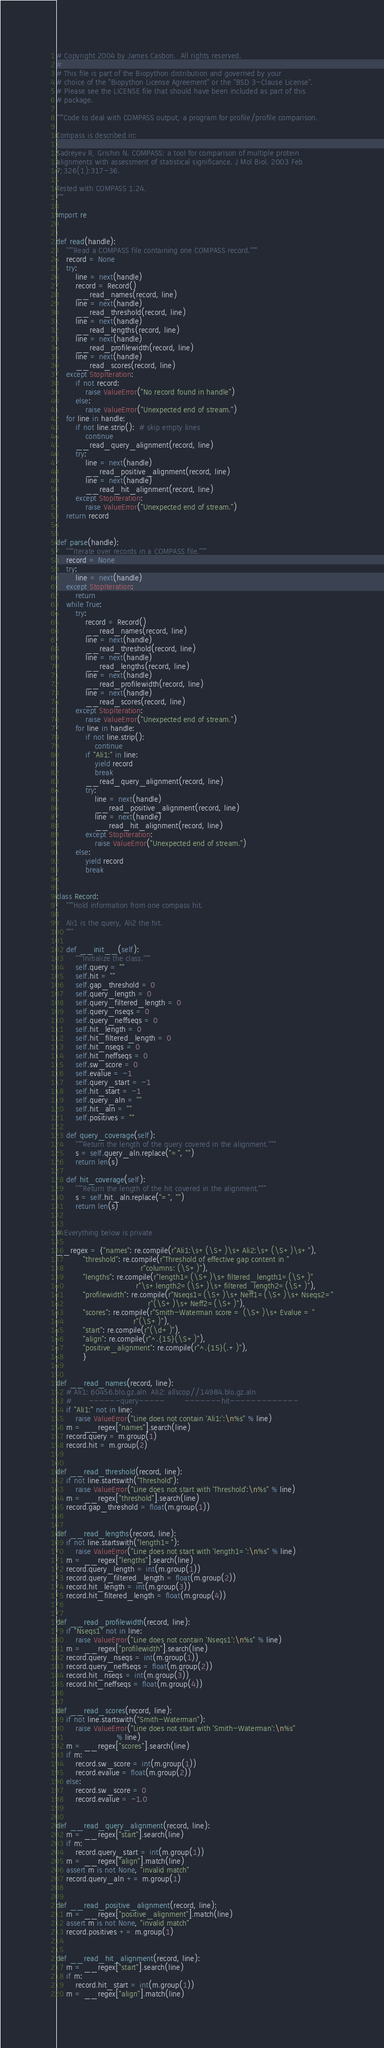<code> <loc_0><loc_0><loc_500><loc_500><_Python_># Copyright 2004 by James Casbon.  All rights reserved.
#
# This file is part of the Biopython distribution and governed by your
# choice of the "Biopython License Agreement" or the "BSD 3-Clause License".
# Please see the LICENSE file that should have been included as part of this
# package.

"""Code to deal with COMPASS output, a program for profile/profile comparison.

Compass is described in:

Sadreyev R, Grishin N. COMPASS: a tool for comparison of multiple protein
alignments with assessment of statistical significance. J Mol Biol. 2003 Feb
7;326(1):317-36.

Tested with COMPASS 1.24.
"""

import re


def read(handle):
    """Read a COMPASS file containing one COMPASS record."""
    record = None
    try:
        line = next(handle)
        record = Record()
        __read_names(record, line)
        line = next(handle)
        __read_threshold(record, line)
        line = next(handle)
        __read_lengths(record, line)
        line = next(handle)
        __read_profilewidth(record, line)
        line = next(handle)
        __read_scores(record, line)
    except StopIteration:
        if not record:
            raise ValueError("No record found in handle")
        else:
            raise ValueError("Unexpected end of stream.")
    for line in handle:
        if not line.strip():  # skip empty lines
            continue
        __read_query_alignment(record, line)
        try:
            line = next(handle)
            __read_positive_alignment(record, line)
            line = next(handle)
            __read_hit_alignment(record, line)
        except StopIteration:
            raise ValueError("Unexpected end of stream.")
    return record


def parse(handle):
    """Iterate over records in a COMPASS file."""
    record = None
    try:
        line = next(handle)
    except StopIteration:
        return
    while True:
        try:
            record = Record()
            __read_names(record, line)
            line = next(handle)
            __read_threshold(record, line)
            line = next(handle)
            __read_lengths(record, line)
            line = next(handle)
            __read_profilewidth(record, line)
            line = next(handle)
            __read_scores(record, line)
        except StopIteration:
            raise ValueError("Unexpected end of stream.")
        for line in handle:
            if not line.strip():
                continue
            if "Ali1:" in line:
                yield record
                break
            __read_query_alignment(record, line)
            try:
                line = next(handle)
                __read_positive_alignment(record, line)
                line = next(handle)
                __read_hit_alignment(record, line)
            except StopIteration:
                raise ValueError("Unexpected end of stream.")
        else:
            yield record
            break


class Record:
    """Hold information from one compass hit.

    Ali1 is the query, Ali2 the hit.
    """

    def __init__(self):
        """Initialize the class."""
        self.query = ""
        self.hit = ""
        self.gap_threshold = 0
        self.query_length = 0
        self.query_filtered_length = 0
        self.query_nseqs = 0
        self.query_neffseqs = 0
        self.hit_length = 0
        self.hit_filtered_length = 0
        self.hit_nseqs = 0
        self.hit_neffseqs = 0
        self.sw_score = 0
        self.evalue = -1
        self.query_start = -1
        self.hit_start = -1
        self.query_aln = ""
        self.hit_aln = ""
        self.positives = ""

    def query_coverage(self):
        """Return the length of the query covered in the alignment."""
        s = self.query_aln.replace("=", "")
        return len(s)

    def hit_coverage(self):
        """Return the length of the hit covered in the alignment."""
        s = self.hit_aln.replace("=", "")
        return len(s)


# Everything below is private

__regex = {"names": re.compile(r"Ali1:\s+(\S+)\s+Ali2:\s+(\S+)\s+"),
           "threshold": re.compile(r"Threshold of effective gap content in "
                                   r"columns: (\S+)"),
           "lengths": re.compile(r"length1=(\S+)\s+filtered_length1=(\S+)"
                                 r"\s+length2=(\S+)\s+filtered_length2=(\S+)"),
           "profilewidth": re.compile(r"Nseqs1=(\S+)\s+Neff1=(\S+)\s+Nseqs2="
                                      r"(\S+)\s+Neff2=(\S+)"),
           "scores": re.compile(r"Smith-Waterman score = (\S+)\s+Evalue = "
                                r"(\S+)"),
           "start": re.compile(r"(\d+)"),
           "align": re.compile(r"^.{15}(\S+)"),
           "positive_alignment": re.compile(r"^.{15}(.+)"),
           }


def __read_names(record, line):
    # Ali1: 60456.blo.gz.aln  Ali2: allscop//14984.blo.gz.aln
    #       ------query-----        -------hit-------------
    if "Ali1:" not in line:
        raise ValueError("Line does not contain 'Ali1:':\n%s" % line)
    m = __regex["names"].search(line)
    record.query = m.group(1)
    record.hit = m.group(2)


def __read_threshold(record, line):
    if not line.startswith("Threshold"):
        raise ValueError("Line does not start with 'Threshold':\n%s" % line)
    m = __regex["threshold"].search(line)
    record.gap_threshold = float(m.group(1))


def __read_lengths(record, line):
    if not line.startswith("length1="):
        raise ValueError("Line does not start with 'length1=':\n%s" % line)
    m = __regex["lengths"].search(line)
    record.query_length = int(m.group(1))
    record.query_filtered_length = float(m.group(2))
    record.hit_length = int(m.group(3))
    record.hit_filtered_length = float(m.group(4))


def __read_profilewidth(record, line):
    if "Nseqs1" not in line:
        raise ValueError("Line does not contain 'Nseqs1':\n%s" % line)
    m = __regex["profilewidth"].search(line)
    record.query_nseqs = int(m.group(1))
    record.query_neffseqs = float(m.group(2))
    record.hit_nseqs = int(m.group(3))
    record.hit_neffseqs = float(m.group(4))


def __read_scores(record, line):
    if not line.startswith("Smith-Waterman"):
        raise ValueError("Line does not start with 'Smith-Waterman':\n%s"
                         % line)
    m = __regex["scores"].search(line)
    if m:
        record.sw_score = int(m.group(1))
        record.evalue = float(m.group(2))
    else:
        record.sw_score = 0
        record.evalue = -1.0


def __read_query_alignment(record, line):
    m = __regex["start"].search(line)
    if m:
        record.query_start = int(m.group(1))
    m = __regex["align"].match(line)
    assert m is not None, "invalid match"
    record.query_aln += m.group(1)


def __read_positive_alignment(record, line):
    m = __regex["positive_alignment"].match(line)
    assert m is not None, "invalid match"
    record.positives += m.group(1)


def __read_hit_alignment(record, line):
    m = __regex["start"].search(line)
    if m:
        record.hit_start = int(m.group(1))
    m = __regex["align"].match(line)</code> 